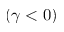<formula> <loc_0><loc_0><loc_500><loc_500>( \gamma < 0 )</formula> 